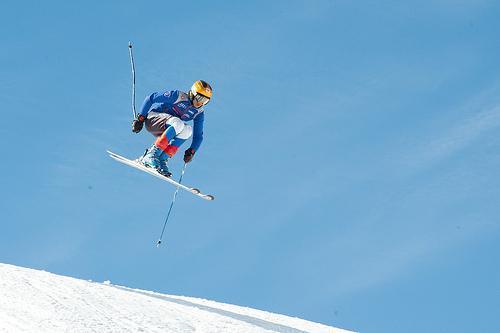How many people are in this picture?
Give a very brief answer. 1. 